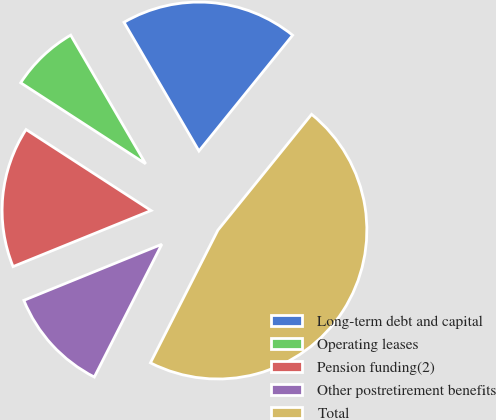<chart> <loc_0><loc_0><loc_500><loc_500><pie_chart><fcel>Long-term debt and capital<fcel>Operating leases<fcel>Pension funding(2)<fcel>Other postretirement benefits<fcel>Total<nl><fcel>19.22%<fcel>7.45%<fcel>15.3%<fcel>11.37%<fcel>46.66%<nl></chart> 